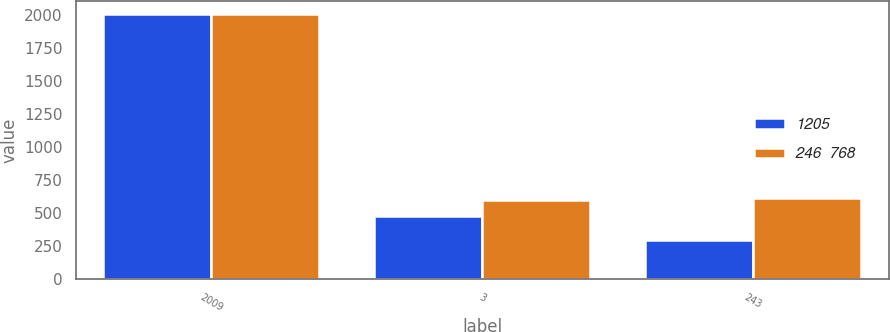Convert chart to OTSL. <chart><loc_0><loc_0><loc_500><loc_500><stacked_bar_chart><ecel><fcel>2009<fcel>3<fcel>243<nl><fcel>1205<fcel>2008<fcel>478<fcel>290<nl><fcel>246  768<fcel>2007<fcel>595<fcel>610<nl></chart> 